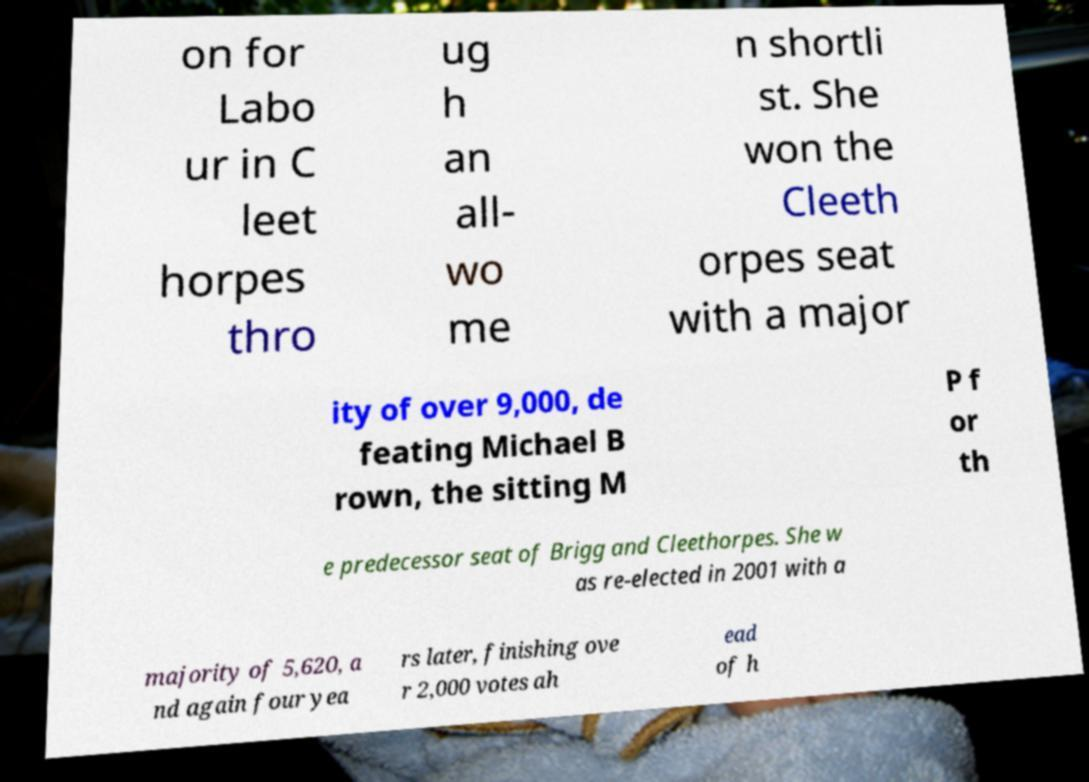Can you accurately transcribe the text from the provided image for me? on for Labo ur in C leet horpes thro ug h an all- wo me n shortli st. She won the Cleeth orpes seat with a major ity of over 9,000, de feating Michael B rown, the sitting M P f or th e predecessor seat of Brigg and Cleethorpes. She w as re-elected in 2001 with a majority of 5,620, a nd again four yea rs later, finishing ove r 2,000 votes ah ead of h 